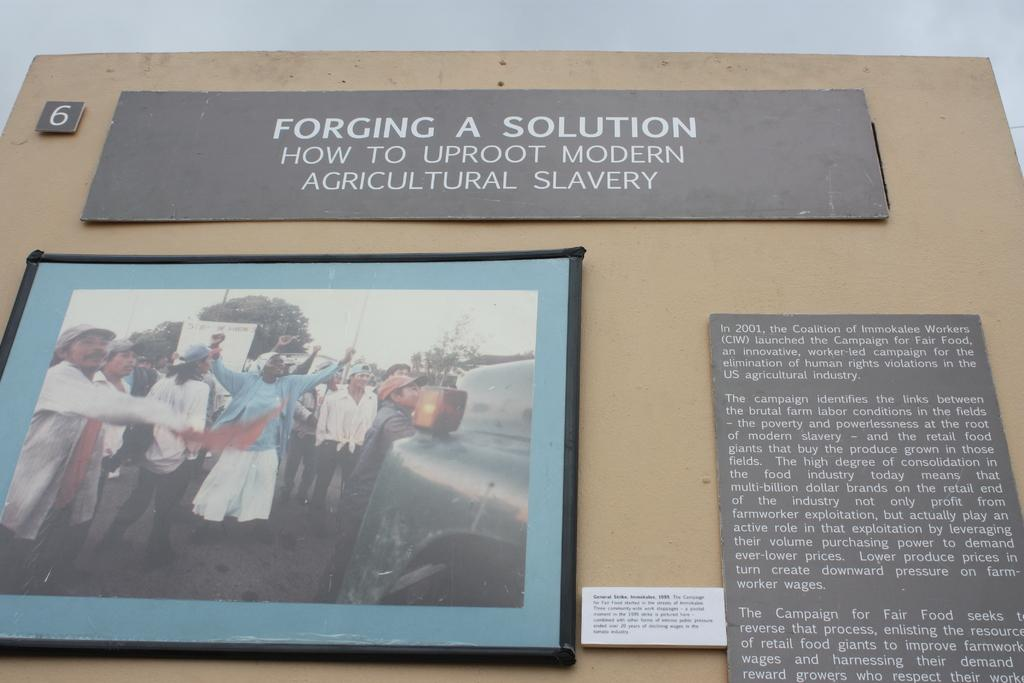<image>
Describe the image concisely. Exhibit 6 consists of three placards, one of which is a photo, that addresses how to solve the problem of modern agricultural slavery. 